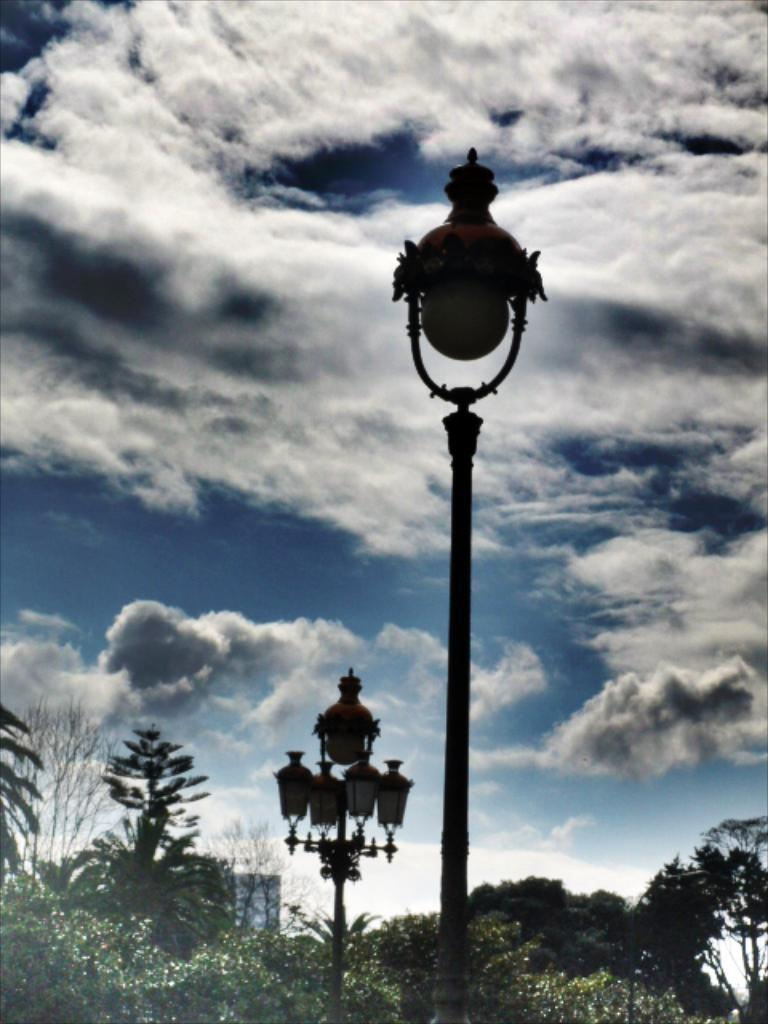What type of vegetation is at the bottom of the image? There are trees at the bottom of the image. What objects can be seen in the middle of the image? There are lamps in the middle of the image. What is visible at the top of the image? The sky is visible at the top of the image. How many pies are being shared between the trees in the image? There are no pies present in the image; it features trees, lamps, and the sky. What type of engine is powering the lamps in the image? There is no engine present in the image; the lamps are likely powered by electricity or another non-mechanical source. 